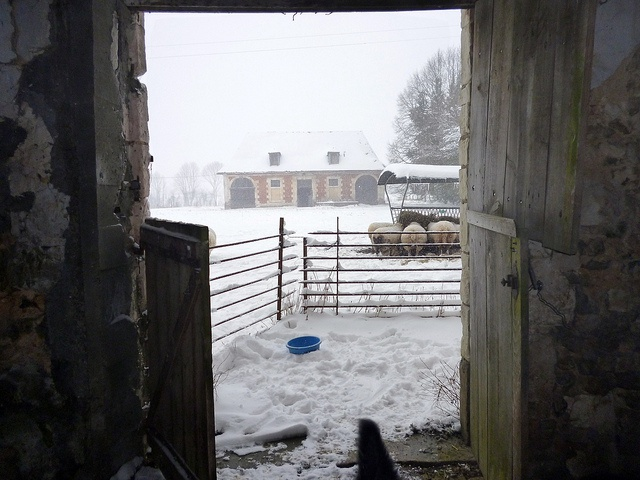Describe the objects in this image and their specific colors. I can see sheep in black, gray, and darkgray tones, sheep in black, gray, darkgray, and lightgray tones, sheep in black, darkgray, and gray tones, bowl in black, darkblue, and gray tones, and sheep in black and gray tones in this image. 